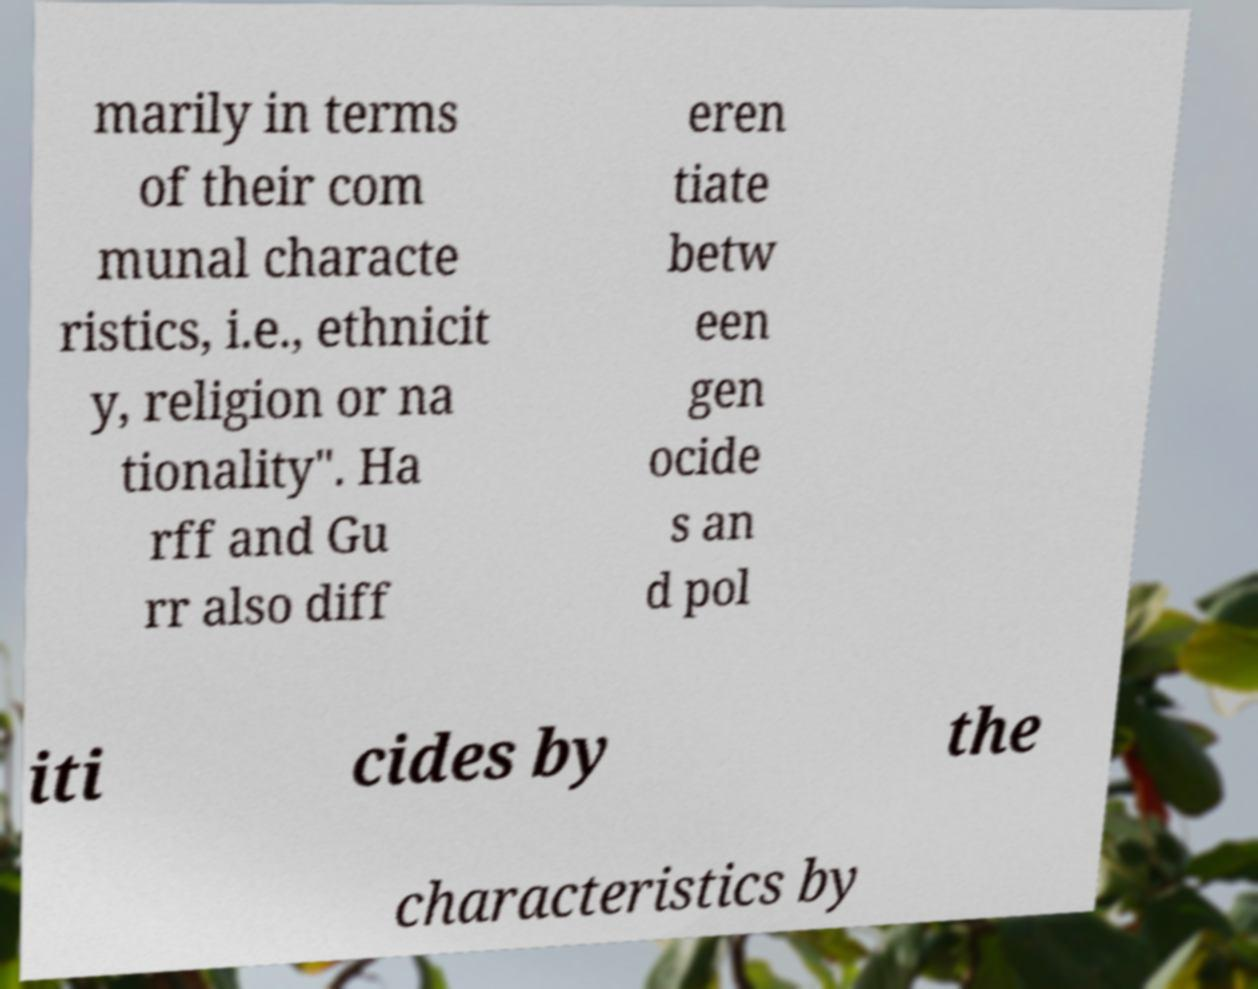What messages or text are displayed in this image? I need them in a readable, typed format. marily in terms of their com munal characte ristics, i.e., ethnicit y, religion or na tionality". Ha rff and Gu rr also diff eren tiate betw een gen ocide s an d pol iti cides by the characteristics by 